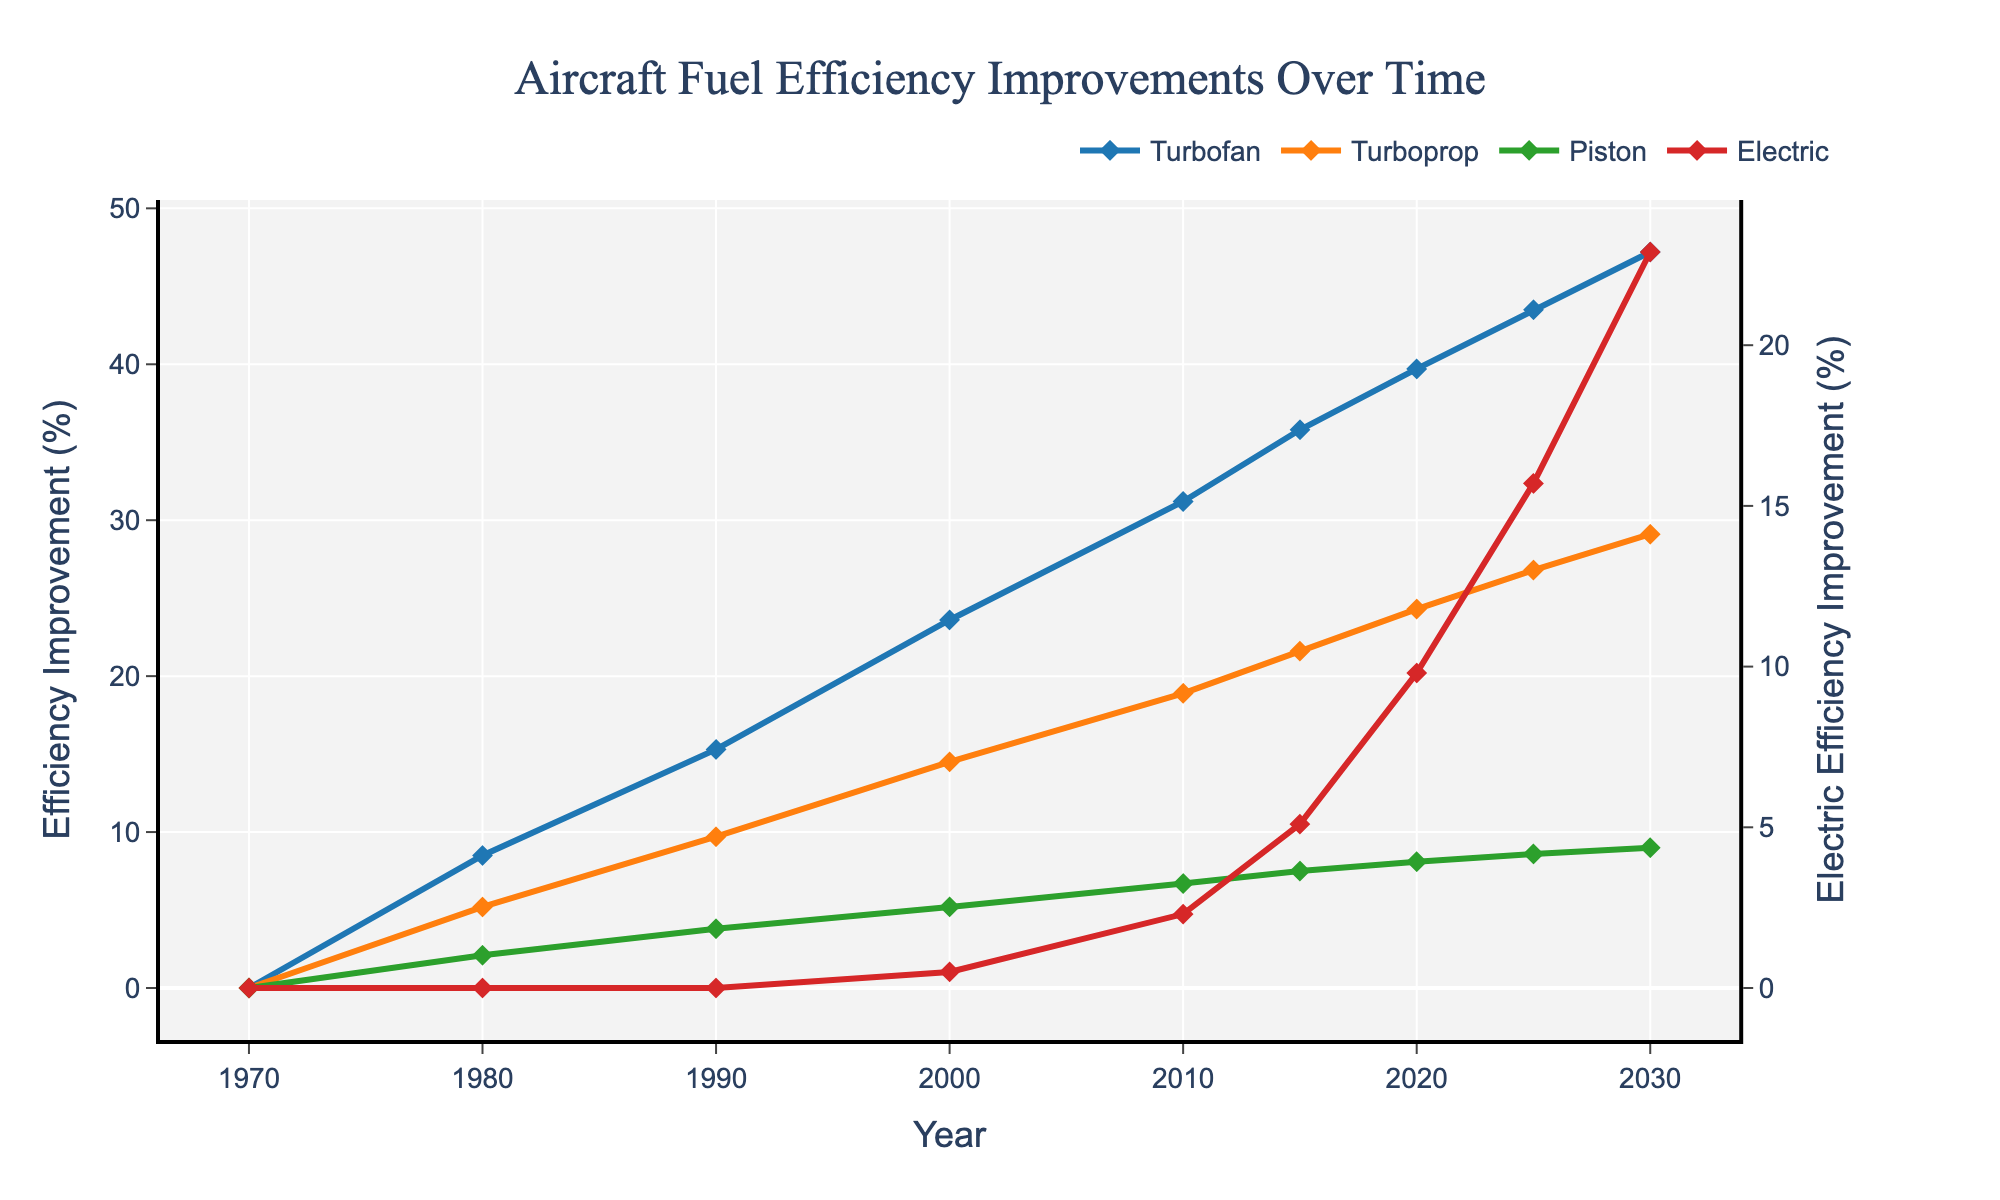What was the fuel efficiency improvement for the Turbofan engine in 2000? Locate the point corresponding to the year 2000 on the x-axis for the Turbofan engine, represented by the blue line. This point is at 23.6.
Answer: 23.6 Which engine type showed the highest fuel efficiency improvement in 2020? Check the vertical alignment of all data points for the year 2020. The Turbofan engine (blue line) is the highest at 39.7.
Answer: Turbofan How much did the Electric engine's efficiency improve from 2000 to 2010? Find the efficiency values for the Electric engine in 2000 and 2010 from the red line, which are 0.5 and 2.3 respectively. Subtract the 2000 value from the 2010 value: 2.3 - 0.5 = 1.8.
Answer: 1.8 Between which two years did the Turboprop engine show the greatest increase in efficiency improvement? Examine the slopes of the orange line segments between each pair of years. The largest jump appears between 1980 (5.2) and 1990 (9.7), an increase of 4.5.
Answer: 1980 and 1990 What is the difference in fuel efficiency improvement between the Turbofan and the Piston engines in 2025? Find the efficiency values for the Turbofan and Piston engines in 2025, which are 43.5 for Turbofan and 8.6 for Piston. Subtract the Piston value from the Turbofan value: 43.5 - 8.6 = 34.9.
Answer: 34.9 Which engine type shows no improvement in the year 1970? Look at the year 1970 on the x-axis and see which lines are at 0%. All engine types are at 0% in 1970.
Answer: All engine types By what percent did the Turboprop engine's efficiency improve from 1990 to 2000? Find the efficiency values for the Turboprop engine in 1990 and 2000 from the orange line, which are 9.7 and 14.5 respectively. Subtract the 1990 value from the 2000 value and calculate the percent increase: (14.5 - 9.7) / 9.7 * 100 ≈ 49.5%.
Answer: 49.5% Compare the efficiency improvement rates of the Piston and Electric engines from 2010 to 2020. Which one had a higher rate of increase? Find the efficiency values for both engines in 2010 and 2020. Piston: 2010 (6.7) to 2020 (8.1), increase of 1.4. Electric: 2010 (2.3) to 2020 (9.8), increase of 7.5. The Electric engine had a higher rate of increase.
Answer: Electric What is the average fuel efficiency improvement for the Turbofan engine over the entire period? Sum the efficiency values for the Turbofan engine across all years and divide by the number of years: (0 + 8.5 + 15.3 + 23.6 + 31.2 + 35.8 + 39.7 + 43.5 + 47.2) / 9 ≈ 27.2
Answer: 27.2 